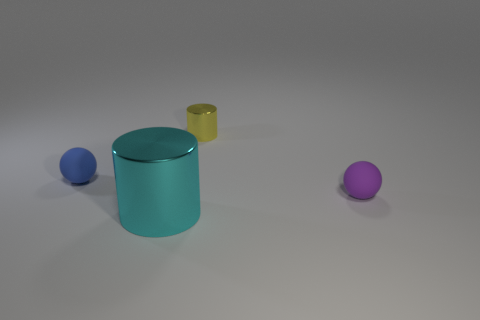Add 1 large objects. How many objects exist? 5 Add 4 small blue matte things. How many small blue matte things are left? 5 Add 3 small gray rubber cylinders. How many small gray rubber cylinders exist? 3 Subtract 0 blue cylinders. How many objects are left? 4 Subtract all cylinders. Subtract all big yellow matte cylinders. How many objects are left? 2 